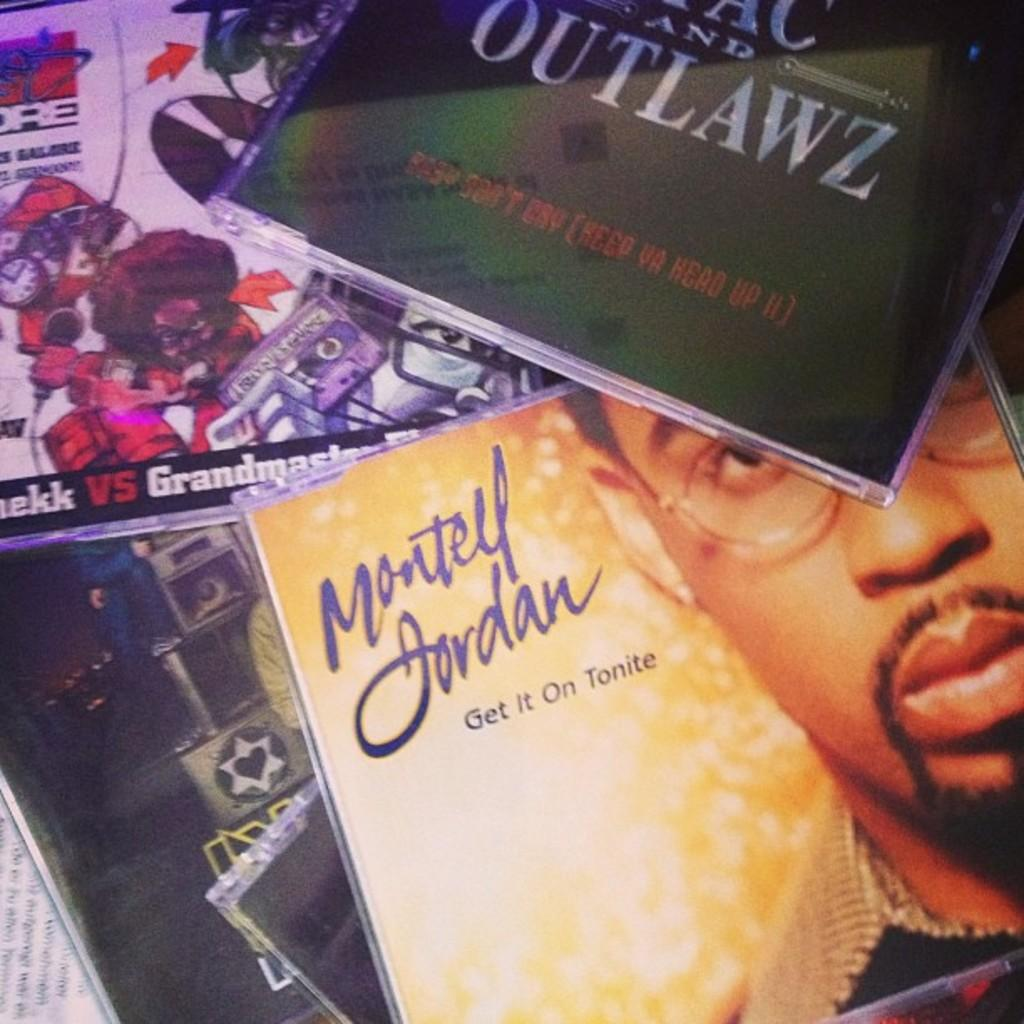<image>
Present a compact description of the photo's key features. A copy of Montell Jordan: Get it on Tonite lies on a surface with several other CDs. 